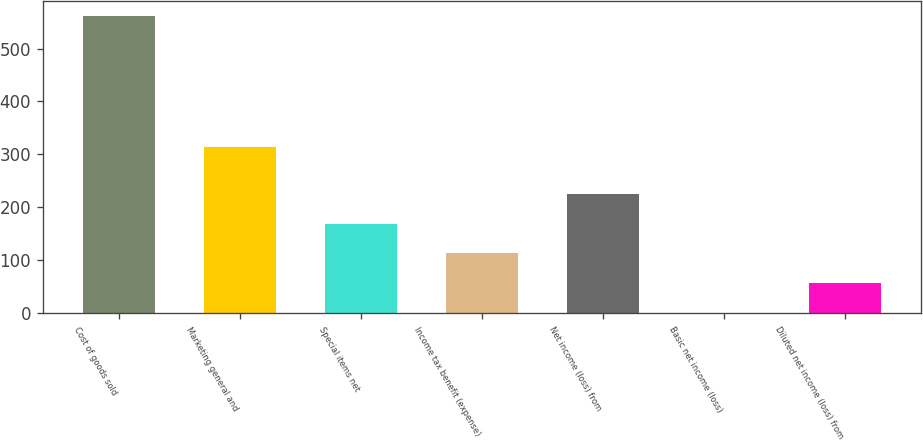<chart> <loc_0><loc_0><loc_500><loc_500><bar_chart><fcel>Cost of goods sold<fcel>Marketing general and<fcel>Special items net<fcel>Income tax benefit (expense)<fcel>Net income (loss) from<fcel>Basic net income (loss)<fcel>Diluted net income (loss) from<nl><fcel>562.2<fcel>313.6<fcel>169.22<fcel>113.08<fcel>225.36<fcel>0.8<fcel>56.94<nl></chart> 